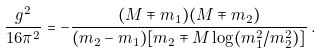<formula> <loc_0><loc_0><loc_500><loc_500>\frac { g ^ { 2 } } { 1 6 \pi ^ { 2 } } = - \frac { ( M \mp m _ { 1 } ) ( M \mp m _ { 2 } ) } { ( m _ { 2 } - m _ { 1 } ) [ m _ { 2 } \mp M \log ( m _ { 1 } ^ { 2 } / m _ { 2 } ^ { 2 } ) ] } \, .</formula> 